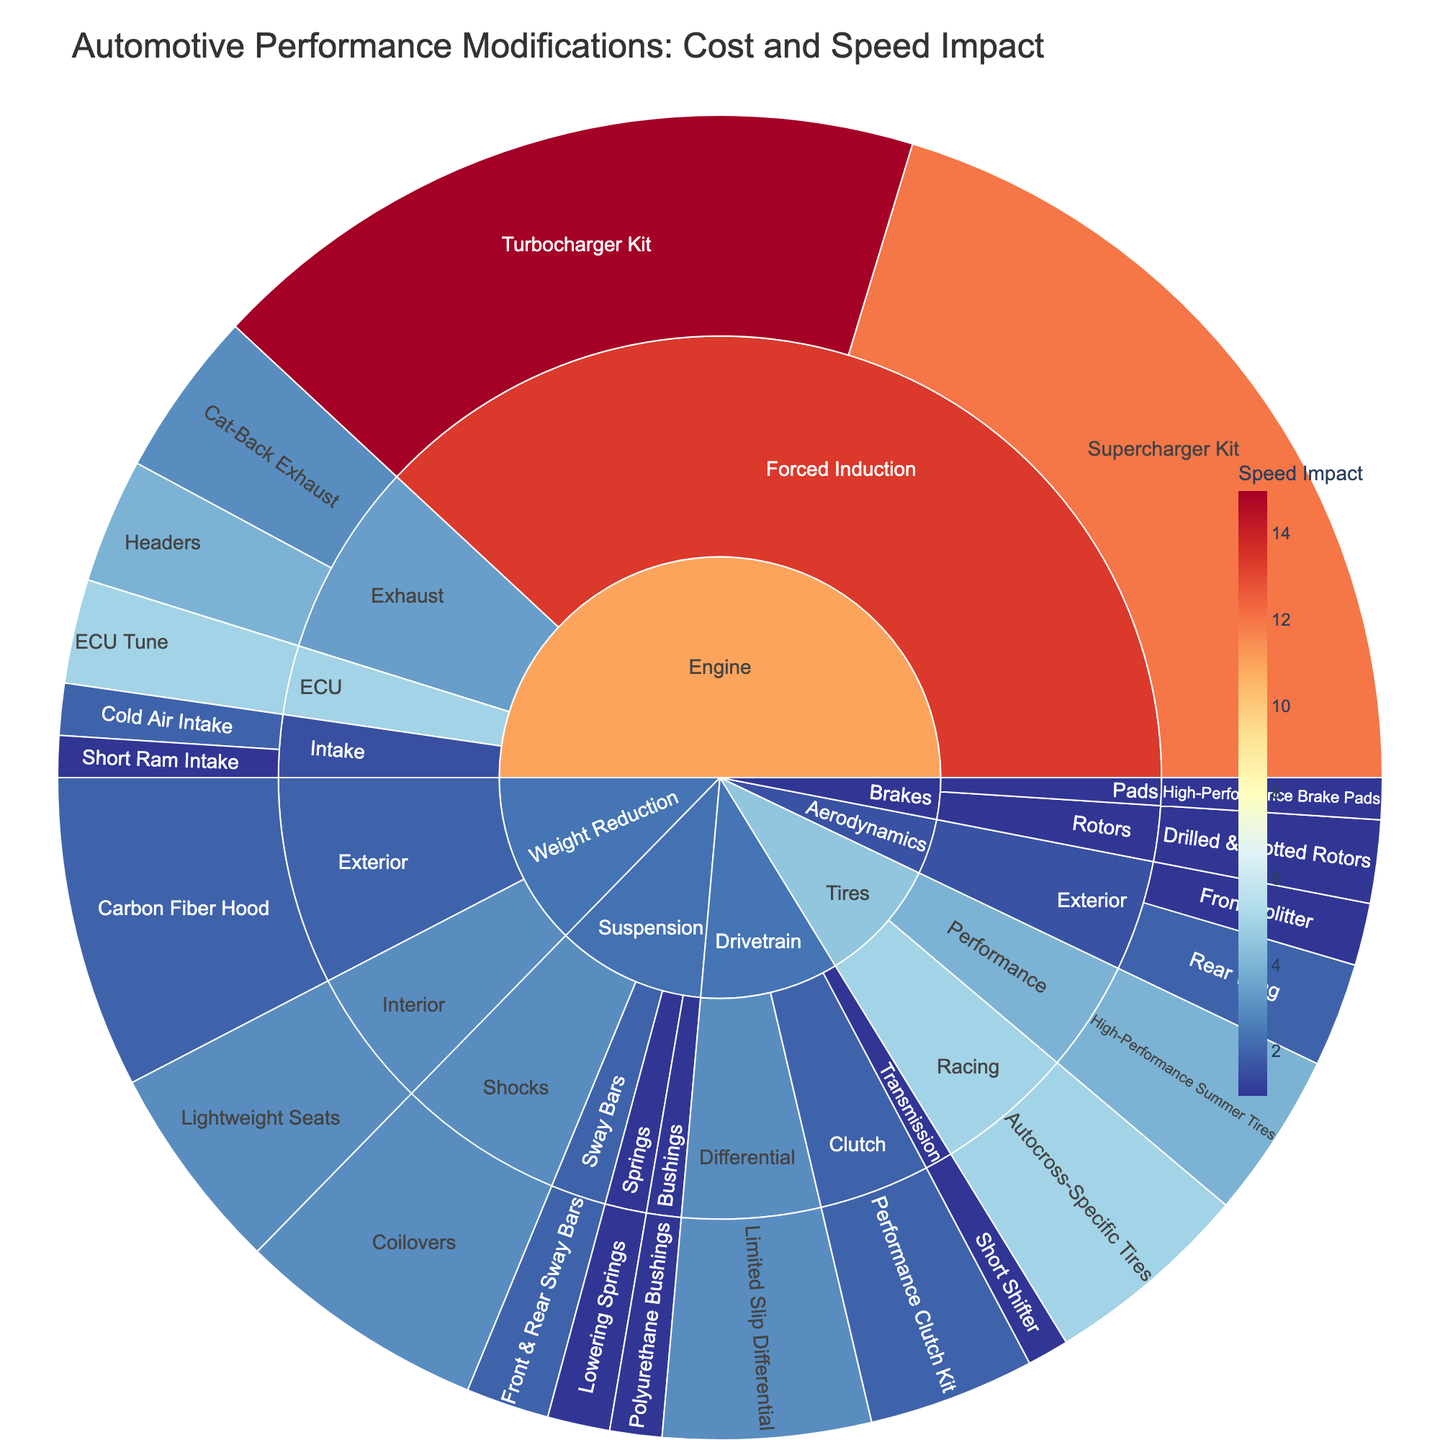What is the category with the most subcategories? By looking at the sunburst plot, each root node represents a category. We count the number of subcategories for each category to find the one with the most subcategories. The Engine category has the most subcategories.
Answer: Engine How much does the cold air intake modification cost? Find the node labeled Cold Air Intake under the Intake subcategory of Engine. The cost is displayed as $250.
Answer: $250 What is the total speed impact of modifications under the ‘Suspension’ category? Inspect each modification within the Suspension category and sum their speed impacts: Lowering Springs (1), Coilovers (3), Front & Rear Sway Bars (2), Polyurethane Bushings (1). The total speed impact is 1+3+2+1=7.
Answer: 7 units Which modification has the highest speed impact? Identify the modification in the sunburst plot with the highest speed impact value. The Turbocharger Kit under Forced Induction in the Engine category has the highest speed impact of 15 units.
Answer: Turbocharger Kit What is the cost difference between a supercharger kit and a turbocharger kit? Find the Supercharger Kit under Forced Induction in the Engine category, and note its cost ($4000). Then, find the Turbocharger Kit and note its cost ($3500). The cost difference is $4000 - $3500 = $500.
Answer: $500 Which has a higher speed impact: High-Performance Summer Tires or Autocross-Specific Tires? Compare the speed impacts of High-Performance Summer Tires (4 units) and Autocross-Specific Tires (5 units) under the Tires category. Autocross-Specific Tires have a higher speed impact.
Answer: Autocross-Specific Tires What is the average cost of modifications in the ‘Brakes’ category? Calculate the average by summing the costs of High-Performance Brake Pads ($200) and Drilled & Slotted Rotors ($400) and dividing by the number of modifications: ($200 + $400) / 2 = $300.
Answer: $300 Which subcategory in the Engine category has the highest cumulative speed impact? Sum the speed impacts of modifications under each subcategory of the Engine category: Intake (3 units), Exhaust (7 units), Forced Induction (27 units), ECU (5 units). Forced Induction has the highest cumulative speed impact.
Answer: Forced Induction What is the total cost of all modifications in the Drivetrain category? Sum the costs of Short Shifter ($200), Limited Slip Differential ($1000), and Performance Clutch Kit ($800): $200 + $1000 + $800 = $2000.
Answer: $2000 Which modifications under the Aerodynamics category have different speed impacts? Identify the modifications under Aerodynamics and their speed impacts: Front Splitter (1 unit) and Rear Wing (2 units). They have different speed impacts.
Answer: Front Splitter, Rear Wing 